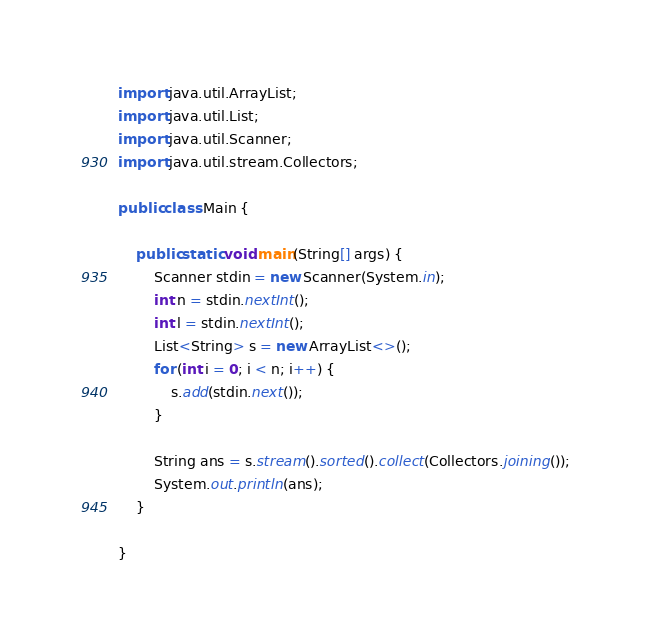<code> <loc_0><loc_0><loc_500><loc_500><_Java_>import java.util.ArrayList;
import java.util.List;
import java.util.Scanner;
import java.util.stream.Collectors;

public class Main {

    public static void main(String[] args) {
        Scanner stdin = new Scanner(System.in);
        int n = stdin.nextInt();
        int l = stdin.nextInt();
        List<String> s = new ArrayList<>();
        for (int i = 0; i < n; i++) {
            s.add(stdin.next());
        }
        
        String ans = s.stream().sorted().collect(Collectors.joining());
        System.out.println(ans);
    }

}
</code> 